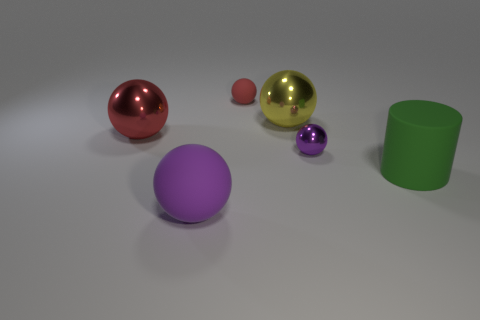Do the small purple object and the large green matte object have the same shape?
Offer a very short reply. No. The purple metal object that is to the right of the small matte thing that is left of the sphere on the right side of the large yellow metallic object is what shape?
Offer a terse response. Sphere. There is a red object left of the small red matte object; does it have the same shape as the green object that is in front of the tiny matte ball?
Your response must be concise. No. Are there any large green cylinders made of the same material as the big red object?
Your answer should be very brief. No. The small object to the left of the purple thing that is behind the purple sphere that is to the left of the tiny purple sphere is what color?
Your answer should be compact. Red. Does the small ball that is on the left side of the large yellow ball have the same material as the purple ball that is behind the big green cylinder?
Your answer should be very brief. No. What shape is the big matte object left of the large yellow ball?
Ensure brevity in your answer.  Sphere. How many things are red objects or spheres that are behind the big purple matte thing?
Provide a short and direct response. 4. Do the cylinder and the small red ball have the same material?
Offer a terse response. Yes. Are there an equal number of small rubber balls that are on the right side of the tiny purple metal sphere and shiny balls that are right of the purple rubber sphere?
Your answer should be very brief. No. 